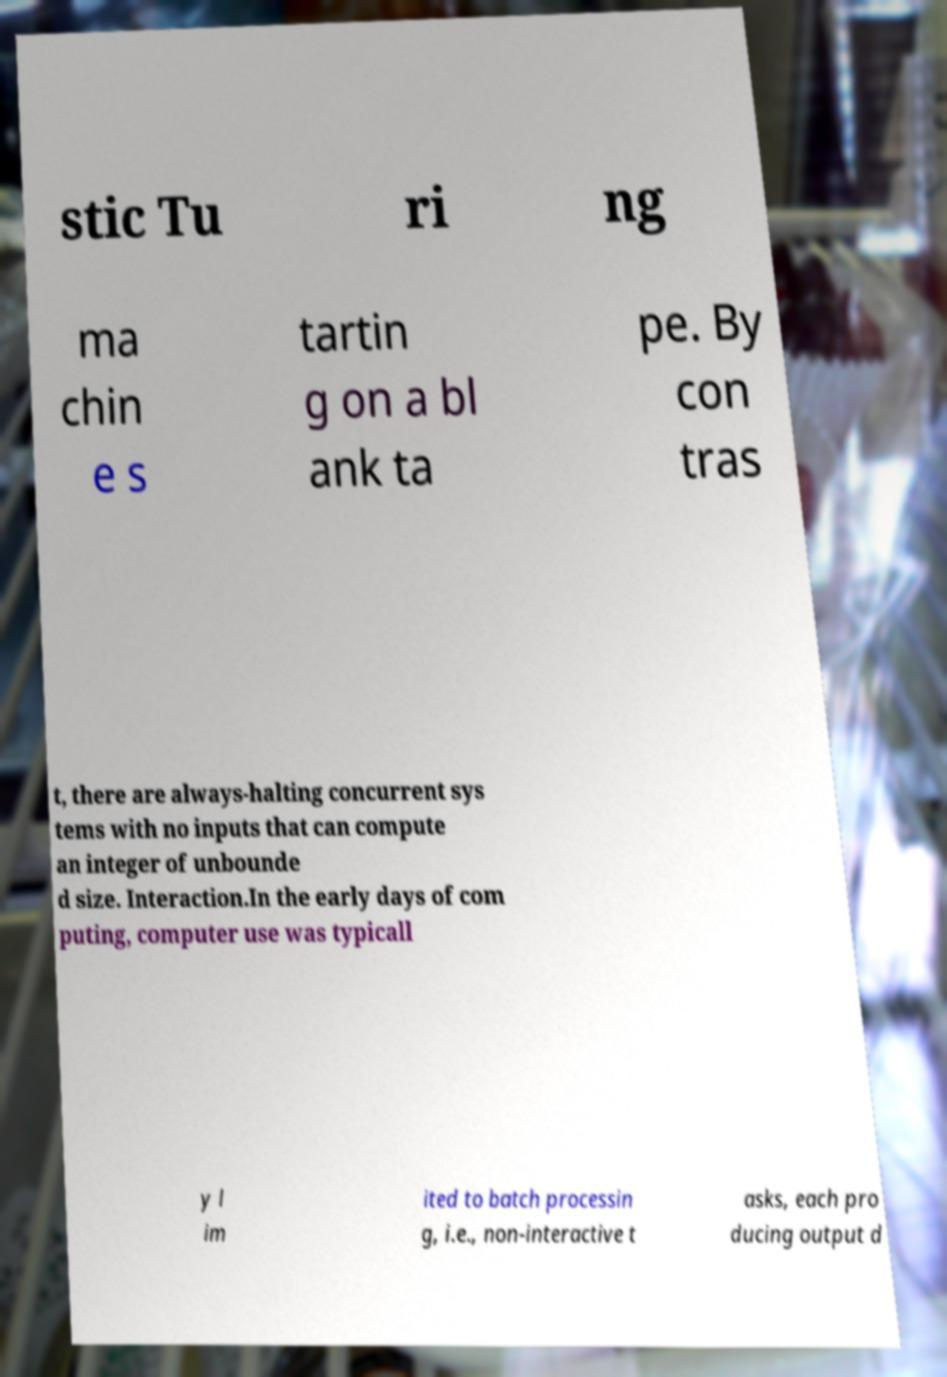For documentation purposes, I need the text within this image transcribed. Could you provide that? stic Tu ri ng ma chin e s tartin g on a bl ank ta pe. By con tras t, there are always-halting concurrent sys tems with no inputs that can compute an integer of unbounde d size. Interaction.In the early days of com puting, computer use was typicall y l im ited to batch processin g, i.e., non-interactive t asks, each pro ducing output d 